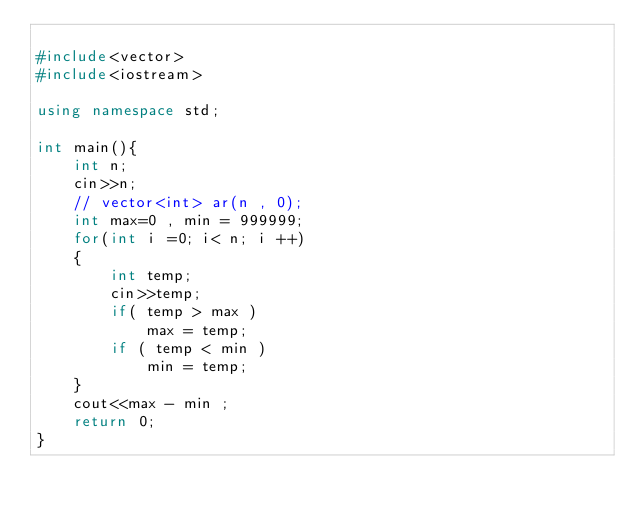<code> <loc_0><loc_0><loc_500><loc_500><_C++_>
#include<vector>
#include<iostream>

using namespace std;

int main(){
    int n;
    cin>>n;
    // vector<int> ar(n , 0);
    int max=0 , min = 999999;
    for(int i =0; i< n; i ++)
    {
        int temp;
        cin>>temp;
        if( temp > max )
            max = temp;
        if ( temp < min )
            min = temp;
    }
    cout<<max - min ;
    return 0;
}</code> 